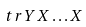Convert formula to latex. <formula><loc_0><loc_0><loc_500><loc_500>\ t r Y X \dots X</formula> 